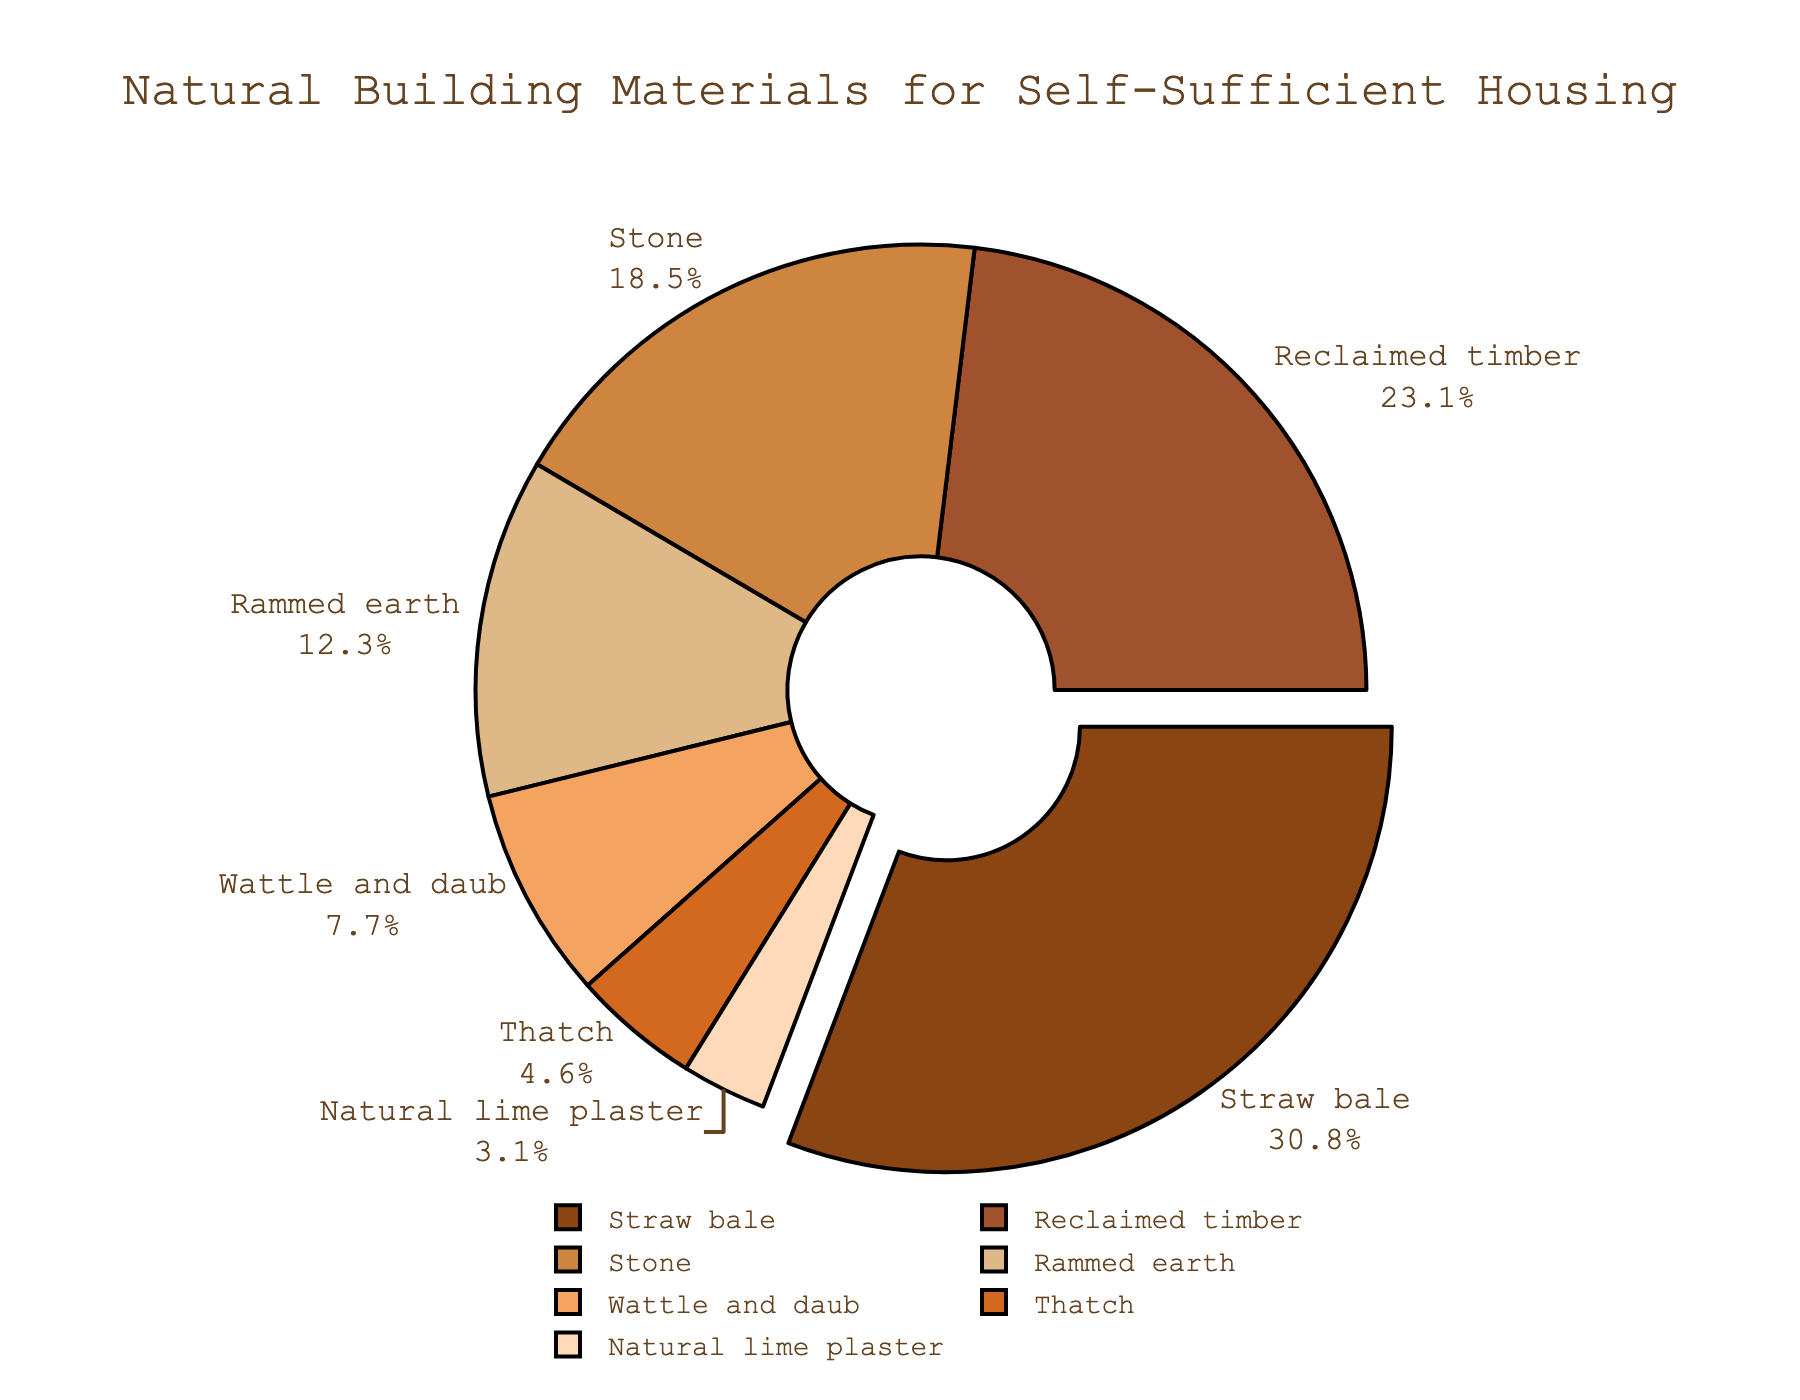What's the material with the highest usage percentage in the chart? The material with the highest percentage is visually shown as pulled out from the chart. Observing the labels, Straw bale is the only segment pulled out.
Answer: Straw bale How much higher is the usage percentage of Straw bale compared to Reclaimed timber? Straw bale has a segment labeled 20%, and Reclaimed timber has a segment labeled 15%. The difference is (20% - 15%) = 5%.
Answer: 5% What materials combined make up less than 10% of the total? The segments with less than 10% are Wattle and daub (5%), Thatch (3%), and Natural lime plaster (2%). Their combined percentage is 5% + 3% + 2% = 10%.
Answer: Wattle and daub, Thatch, Natural lime plaster Which material's segment is shown in a bright ochre-like color? By matching colors to segments, the bright ochre color corresponds to the segment labeled Rammed earth with 8%.
Answer: Rammed earth What is the combined percentage of the three highest materials? The three highest percentages are Straw bale (20%), Reclaimed timber (15%), and Stone (12%). Their combined percentage is 20% + 15% + 12% = 47%.
Answer: 47% Which two materials are closest in their usage percentage? Reclaimed timber is 15% and Stone is 12%. The difference between them is smallest, being (15% - 12%) = 3%.
Answer: Reclaimed timber and Stone What percentage of materials used is less than that of Rammed earth? The materials with less than 8% are Wattle and daub (5%), Thatch (3%), and Natural lime plaster (2%). Adding all these percentages gives 5% + 3% + 2% = 10%.
Answer: 10% Assuming the total usage is 100%, what percentage does not come from Straw bale or Reclaimed timber? Combined percentage of Straw bale (20%) and Reclaimed timber (15%) is 35%. So, the percentage not from these two materials is 100% - 35% = 65%.
Answer: 65% What material has twice the percentage usage of Wattle and daub? Wattle and daub is labeled as 5%, and twice that percentage is 5% * 2 = 10%. Stone, shown as 12%, is closest but not exactly twice. No segment is exactly twice.
Answer: None Which material takes up the smallest portion of the pie? Observing the pie, Natural lime plaster has the smallest percentage, labeled 2%.
Answer: Natural lime plaster 